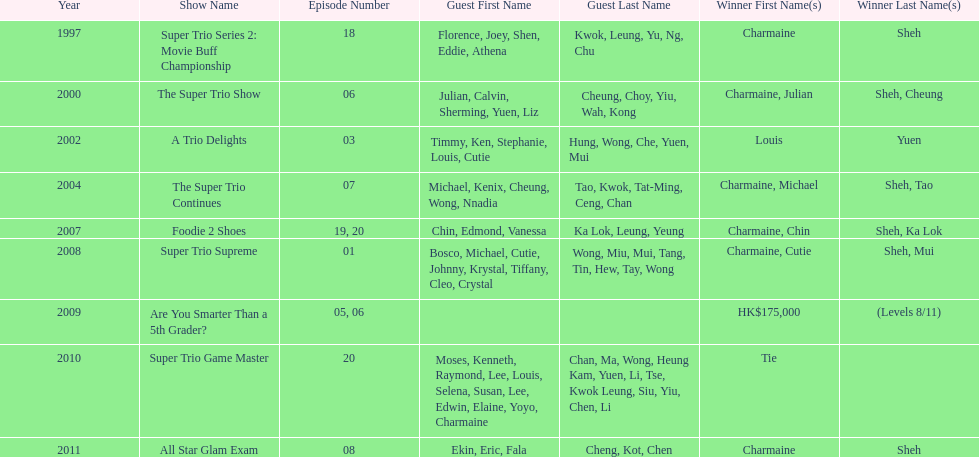How many episodes was charmaine sheh on in the variety show super trio 2: movie buff champions 18. Could you parse the entire table? {'header': ['Year', 'Show Name', 'Episode Number', 'Guest First Name', 'Guest Last Name', 'Winner First Name(s)', 'Winner Last Name(s)'], 'rows': [['1997', 'Super Trio Series 2: Movie Buff Championship', '18', 'Florence, Joey, Shen, Eddie, Athena', 'Kwok, Leung, Yu, Ng, Chu', 'Charmaine', 'Sheh'], ['2000', 'The Super Trio Show', '06', 'Julian, Calvin, Sherming, Yuen, Liz', 'Cheung, Choy, Yiu, Wah, Kong', 'Charmaine, Julian', 'Sheh, Cheung'], ['2002', 'A Trio Delights', '03', 'Timmy, Ken, Stephanie, Louis, Cutie', 'Hung, Wong, Che, Yuen, Mui', 'Louis', 'Yuen'], ['2004', 'The Super Trio Continues', '07', 'Michael, Kenix, Cheung, Wong, Nnadia', 'Tao, Kwok, Tat-Ming, Ceng, Chan', 'Charmaine, Michael', 'Sheh, Tao'], ['2007', 'Foodie 2 Shoes', '19, 20', 'Chin, Edmond, Vanessa', 'Ka Lok, Leung, Yeung', 'Charmaine, Chin', 'Sheh, Ka Lok'], ['2008', 'Super Trio Supreme', '01', 'Bosco, Michael, Cutie, Johnny, Krystal, Tiffany, Cleo, Crystal', 'Wong, Miu, Mui, Tang, Tin, Hew, Tay, Wong', 'Charmaine, Cutie', 'Sheh, Mui'], ['2009', 'Are You Smarter Than a 5th Grader?', '05, 06', '', '', 'HK$175,000', '(Levels 8/11)'], ['2010', 'Super Trio Game Master', '20', 'Moses, Kenneth, Raymond, Lee, Louis, Selena, Susan, Lee, Edwin, Elaine, Yoyo, Charmaine', 'Chan, Ma, Wong, Heung Kam, Yuen, Li, Tse, Kwok Leung, Siu, Yiu, Chen, Li', 'Tie', ''], ['2011', 'All Star Glam Exam', '08', 'Ekin, Eric, Fala', 'Cheng, Kot, Chen', 'Charmaine', 'Sheh']]} 